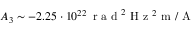<formula> <loc_0><loc_0><loc_500><loc_500>A _ { 3 } \sim - 2 . 2 5 \cdot 1 0 ^ { 2 2 } \, r a d ^ { 2 } H z ^ { 2 } m / A</formula> 